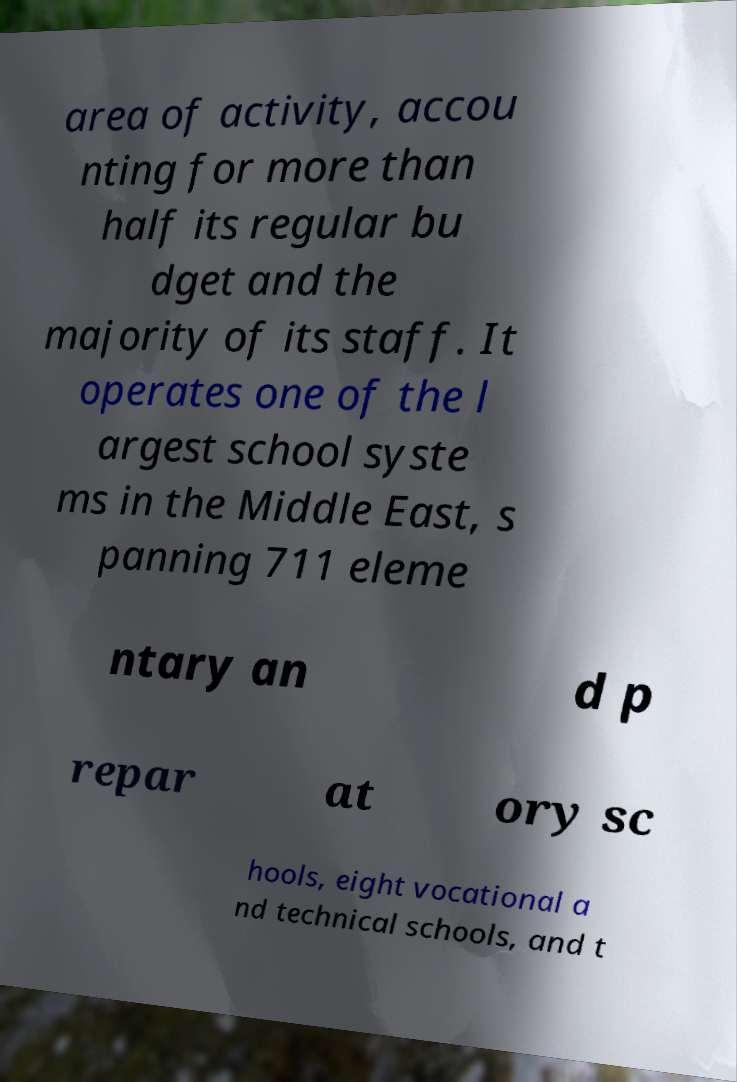I need the written content from this picture converted into text. Can you do that? area of activity, accou nting for more than half its regular bu dget and the majority of its staff. It operates one of the l argest school syste ms in the Middle East, s panning 711 eleme ntary an d p repar at ory sc hools, eight vocational a nd technical schools, and t 